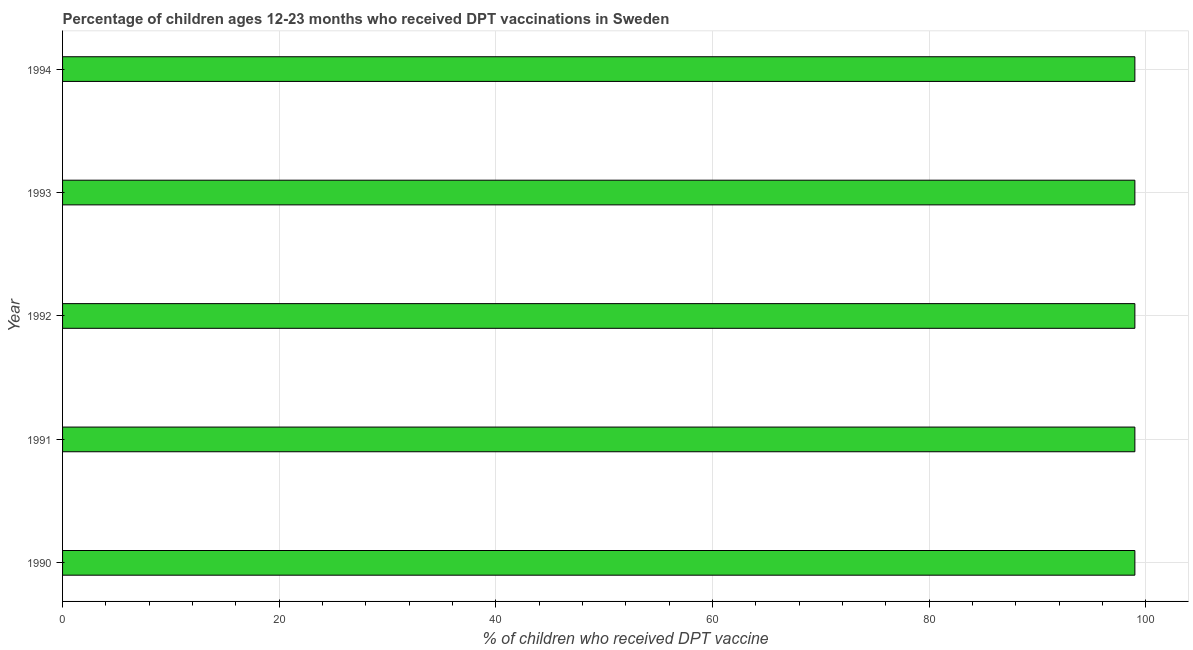Does the graph contain grids?
Provide a succinct answer. Yes. What is the title of the graph?
Offer a very short reply. Percentage of children ages 12-23 months who received DPT vaccinations in Sweden. What is the label or title of the X-axis?
Your answer should be very brief. % of children who received DPT vaccine. Across all years, what is the maximum percentage of children who received dpt vaccine?
Give a very brief answer. 99. In which year was the percentage of children who received dpt vaccine maximum?
Give a very brief answer. 1990. In which year was the percentage of children who received dpt vaccine minimum?
Provide a succinct answer. 1990. What is the sum of the percentage of children who received dpt vaccine?
Make the answer very short. 495. What is the difference between the percentage of children who received dpt vaccine in 1991 and 1994?
Offer a very short reply. 0. What is the average percentage of children who received dpt vaccine per year?
Your answer should be compact. 99. What is the median percentage of children who received dpt vaccine?
Your response must be concise. 99. Do a majority of the years between 1991 and 1990 (inclusive) have percentage of children who received dpt vaccine greater than 96 %?
Provide a short and direct response. No. What is the ratio of the percentage of children who received dpt vaccine in 1992 to that in 1994?
Ensure brevity in your answer.  1. Is the percentage of children who received dpt vaccine in 1991 less than that in 1992?
Your response must be concise. No. Is the difference between the percentage of children who received dpt vaccine in 1990 and 1992 greater than the difference between any two years?
Keep it short and to the point. Yes. How many bars are there?
Offer a very short reply. 5. How many years are there in the graph?
Offer a very short reply. 5. What is the difference between two consecutive major ticks on the X-axis?
Offer a terse response. 20. What is the % of children who received DPT vaccine of 1991?
Keep it short and to the point. 99. What is the % of children who received DPT vaccine in 1992?
Your response must be concise. 99. What is the % of children who received DPT vaccine in 1993?
Provide a succinct answer. 99. What is the % of children who received DPT vaccine of 1994?
Make the answer very short. 99. What is the difference between the % of children who received DPT vaccine in 1990 and 1992?
Provide a short and direct response. 0. What is the difference between the % of children who received DPT vaccine in 1990 and 1993?
Provide a short and direct response. 0. What is the difference between the % of children who received DPT vaccine in 1991 and 1993?
Provide a succinct answer. 0. What is the difference between the % of children who received DPT vaccine in 1992 and 1993?
Keep it short and to the point. 0. What is the difference between the % of children who received DPT vaccine in 1992 and 1994?
Provide a succinct answer. 0. What is the ratio of the % of children who received DPT vaccine in 1990 to that in 1992?
Your response must be concise. 1. What is the ratio of the % of children who received DPT vaccine in 1990 to that in 1993?
Your response must be concise. 1. What is the ratio of the % of children who received DPT vaccine in 1991 to that in 1993?
Ensure brevity in your answer.  1. What is the ratio of the % of children who received DPT vaccine in 1991 to that in 1994?
Keep it short and to the point. 1. 